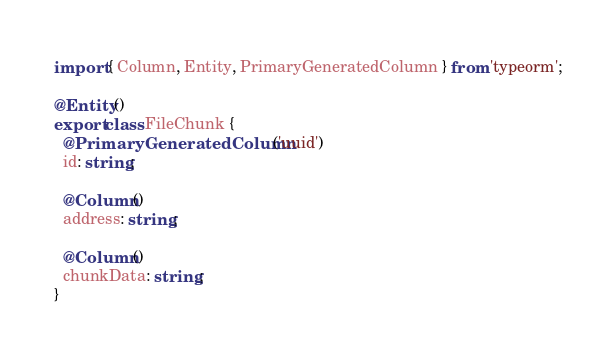<code> <loc_0><loc_0><loc_500><loc_500><_TypeScript_>import { Column, Entity, PrimaryGeneratedColumn } from 'typeorm';

@Entity()
export class FileChunk {
  @PrimaryGeneratedColumn('uuid')
  id: string;

  @Column()
  address: string;

  @Column()
  chunkData: string;
}
</code> 